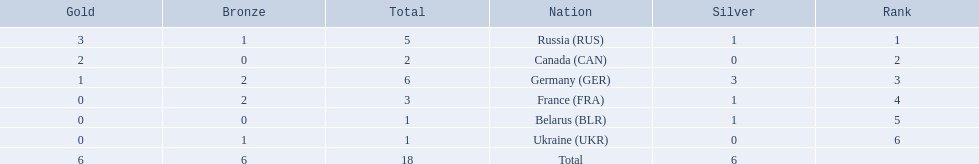What are all the countries in the 1994 winter olympics biathlon? Russia (RUS), Canada (CAN), Germany (GER), France (FRA), Belarus (BLR), Ukraine (UKR). Which of these received at least one gold medal? Russia (RUS), Canada (CAN), Germany (GER). Which of these received no silver or bronze medals? Canada (CAN). 